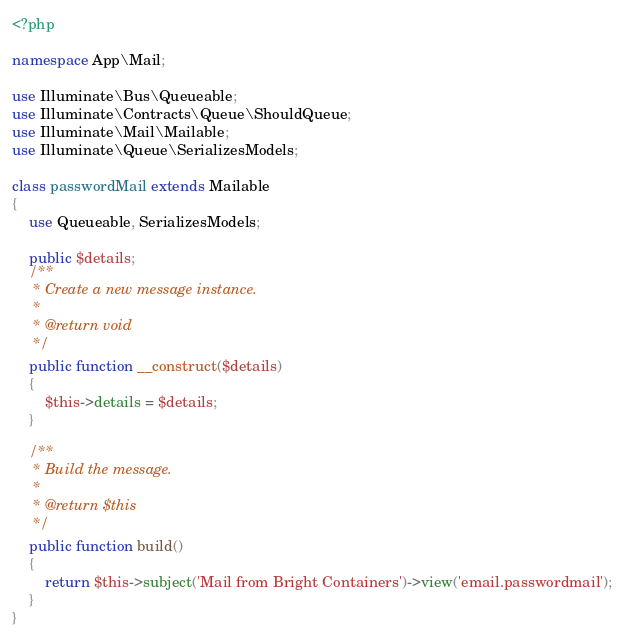<code> <loc_0><loc_0><loc_500><loc_500><_PHP_><?php

namespace App\Mail;

use Illuminate\Bus\Queueable;
use Illuminate\Contracts\Queue\ShouldQueue;
use Illuminate\Mail\Mailable;
use Illuminate\Queue\SerializesModels;

class passwordMail extends Mailable
{
    use Queueable, SerializesModels;

    public $details;
    /**
     * Create a new message instance.
     *
     * @return void
     */
    public function __construct($details)
    {
        $this->details = $details;
    }

    /**
     * Build the message.
     *
     * @return $this
     */
    public function build()
    {
        return $this->subject('Mail from Bright Containers')->view('email.passwordmail');
    }
}
</code> 